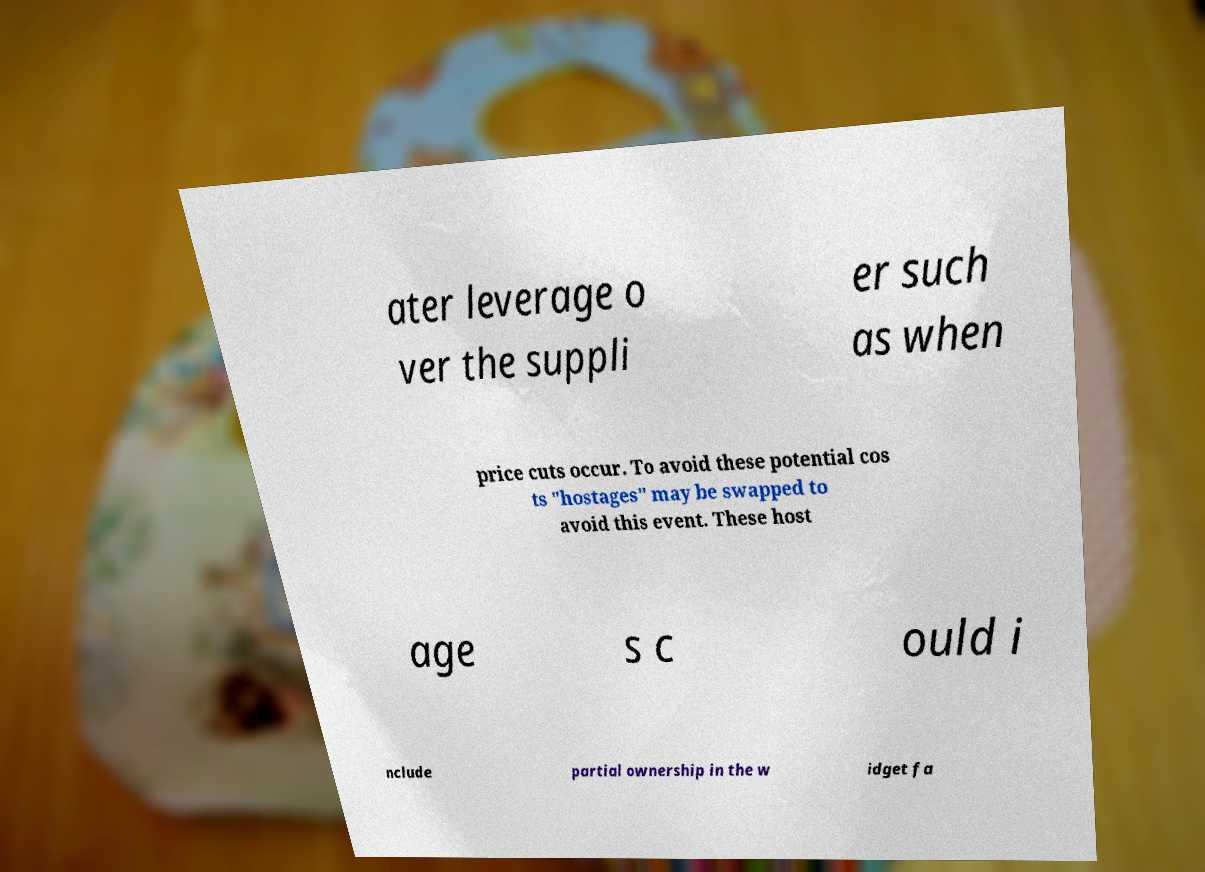For documentation purposes, I need the text within this image transcribed. Could you provide that? ater leverage o ver the suppli er such as when price cuts occur. To avoid these potential cos ts "hostages" may be swapped to avoid this event. These host age s c ould i nclude partial ownership in the w idget fa 